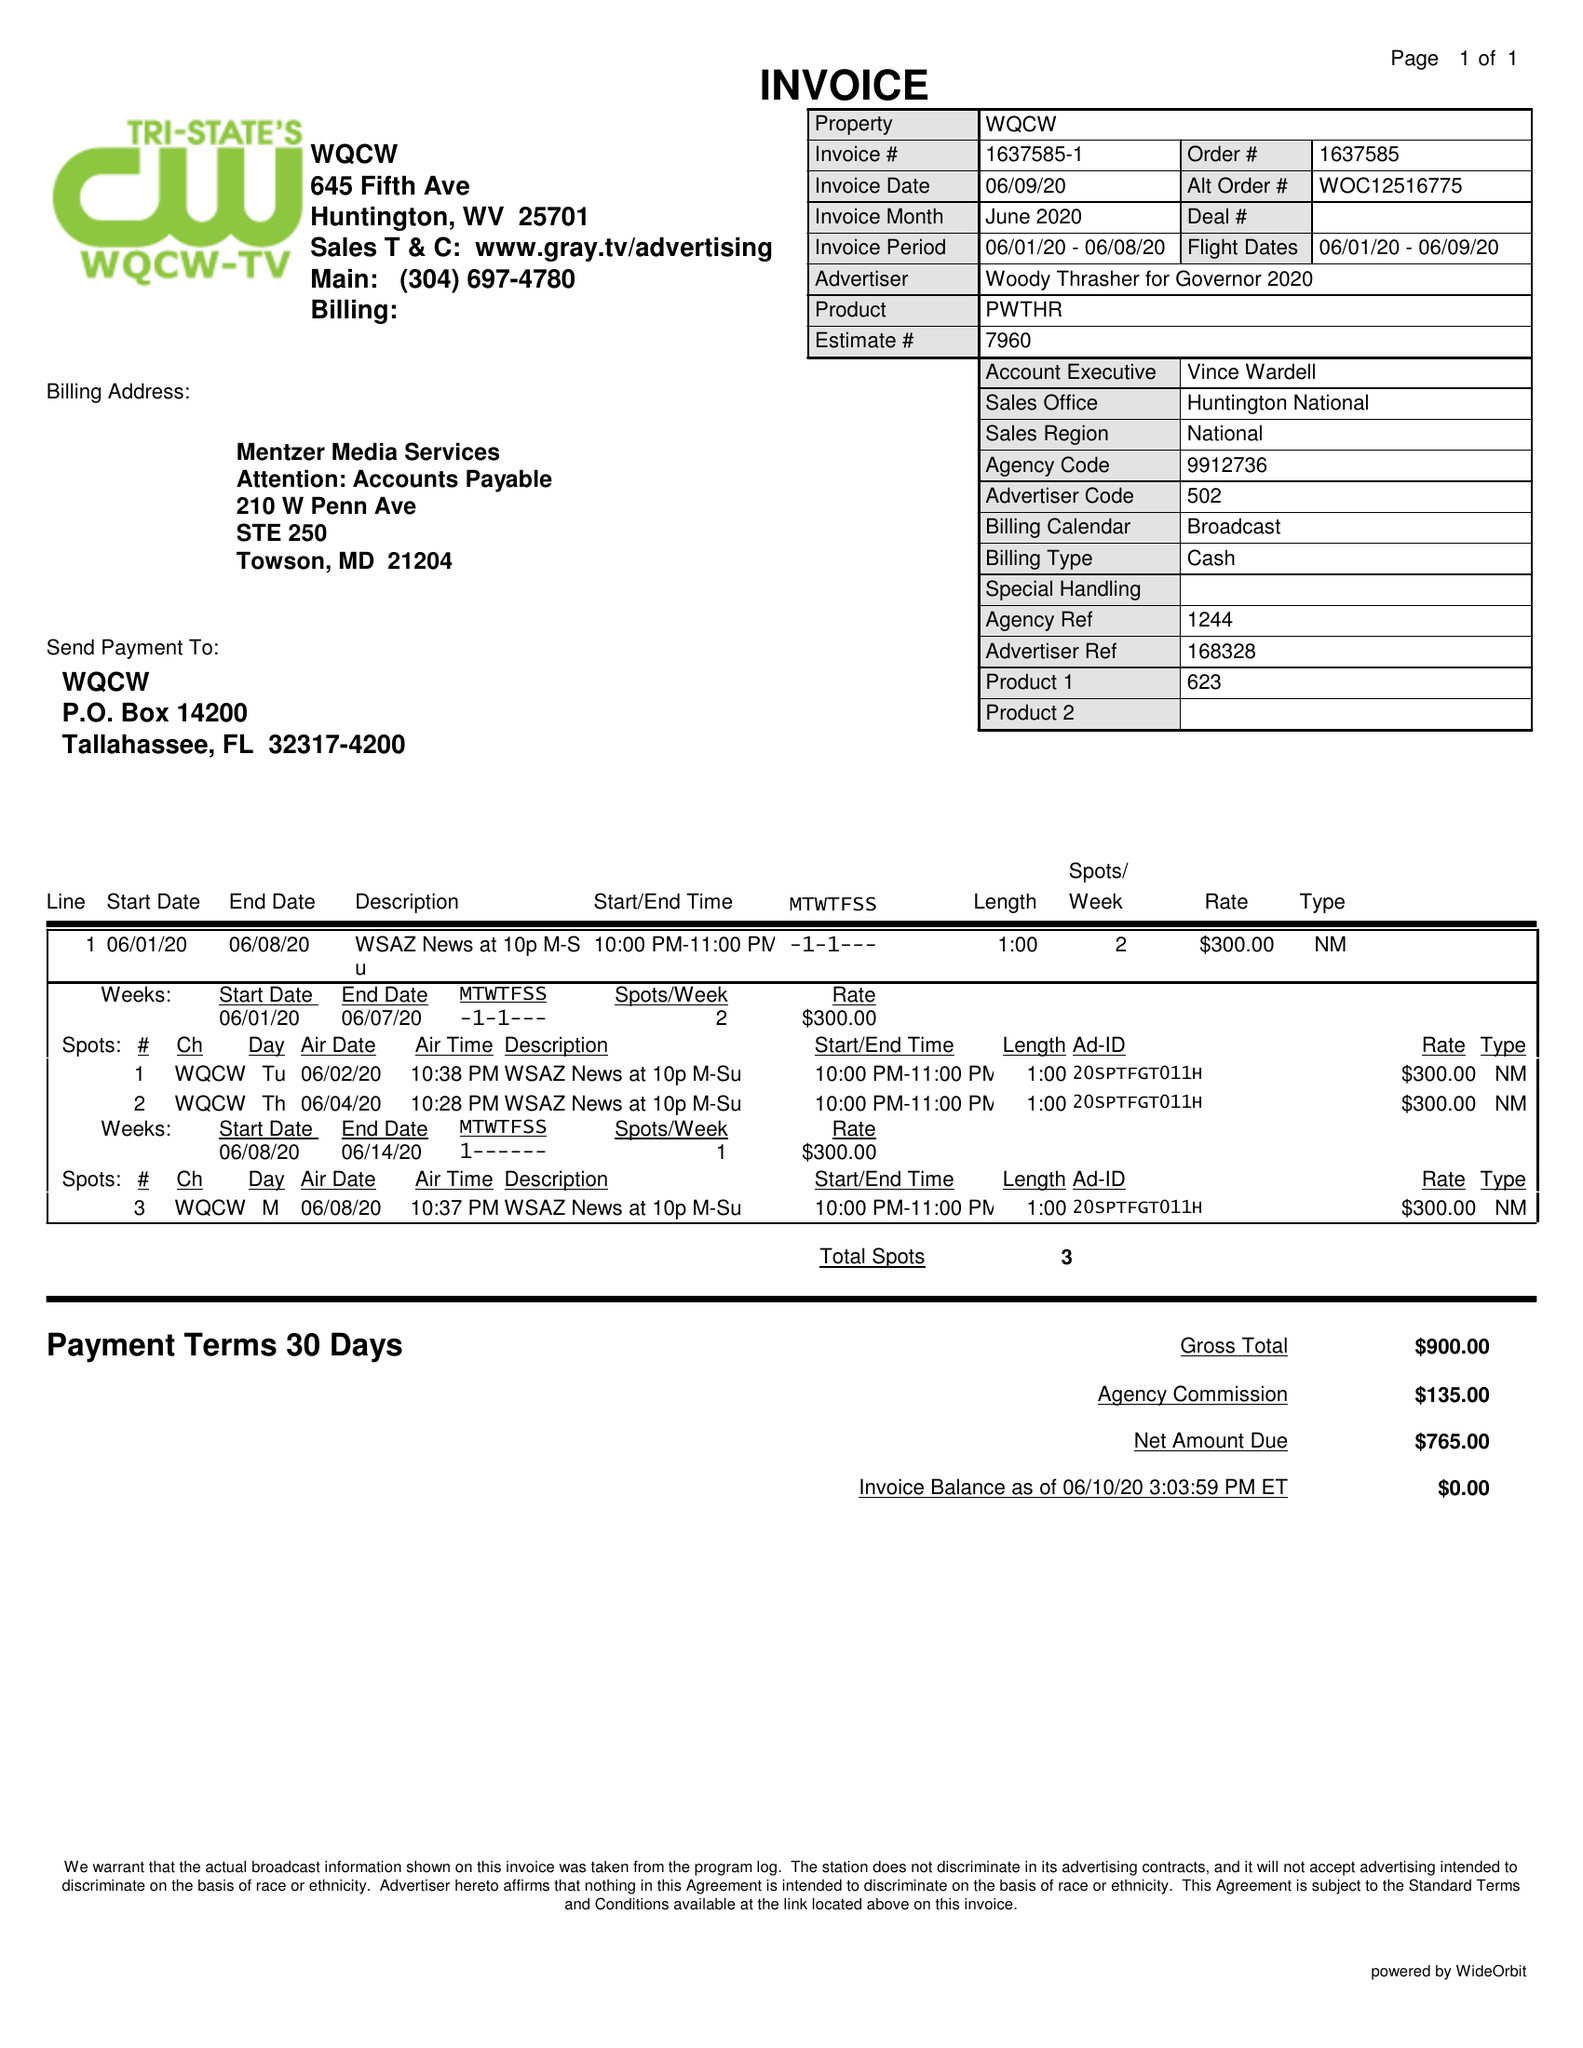What is the value for the gross_amount?
Answer the question using a single word or phrase. 900.00 